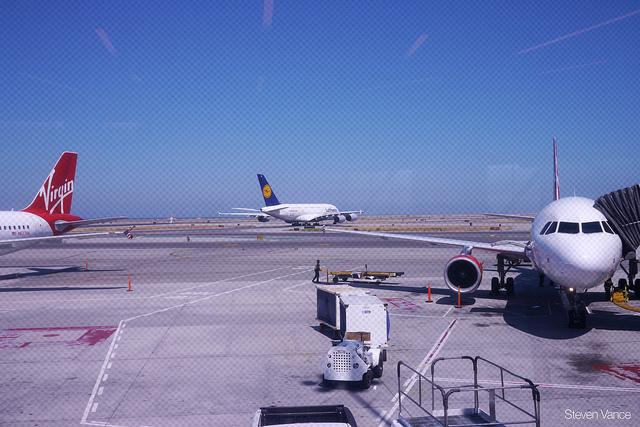Who owns the vehicle on the left? virgin 